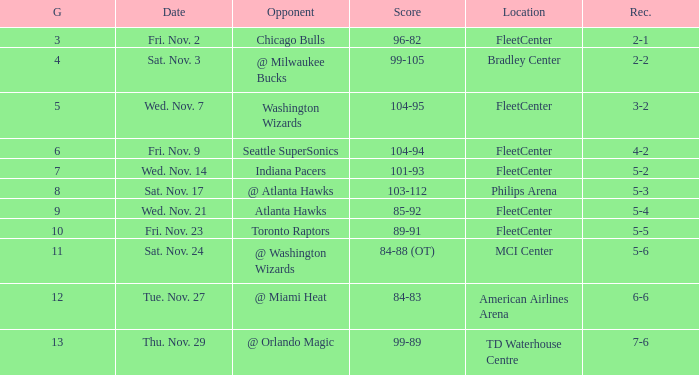On what date did a game higher than 10 have a score of 99-89? Thu. Nov. 29. 